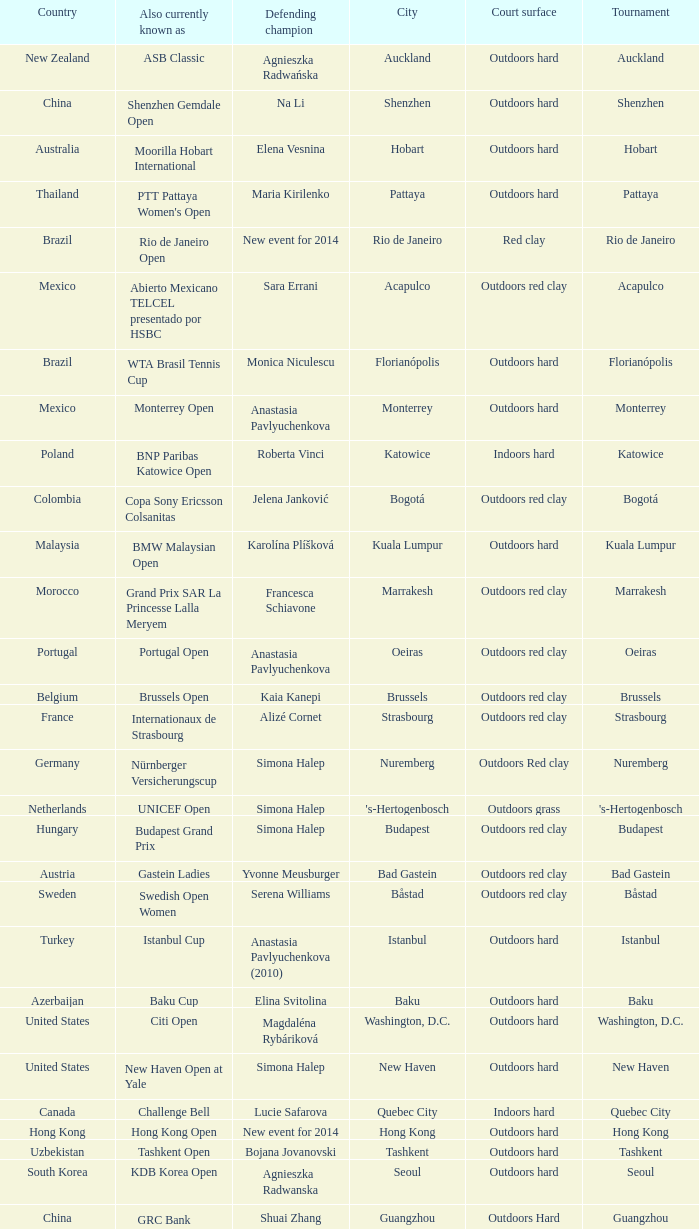What tournament is in katowice? Katowice. 